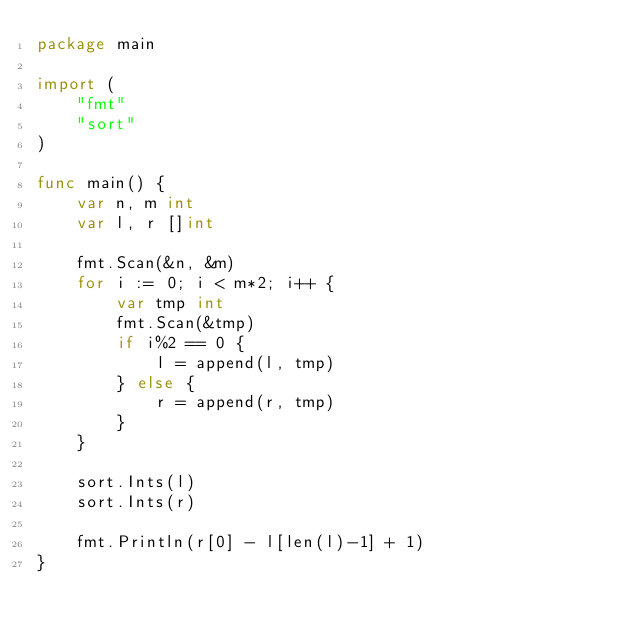Convert code to text. <code><loc_0><loc_0><loc_500><loc_500><_Go_>package main

import (
	"fmt"
	"sort"
)

func main() {
	var n, m int
	var l, r []int

	fmt.Scan(&n, &m)
	for i := 0; i < m*2; i++ {
		var tmp int
		fmt.Scan(&tmp)
		if i%2 == 0 {
			l = append(l, tmp)
		} else {
			r = append(r, tmp)
		}
	}

	sort.Ints(l)
	sort.Ints(r)

	fmt.Println(r[0] - l[len(l)-1] + 1)
}
</code> 